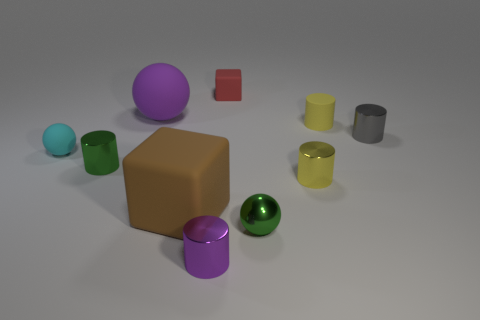How many objects are there, and can you identify the one that appears the most reflective? There are a total of nine objects present. The silver cylinder appears to be the most reflective, as it shows a high level of glossiness indicative of a metallic surface. 